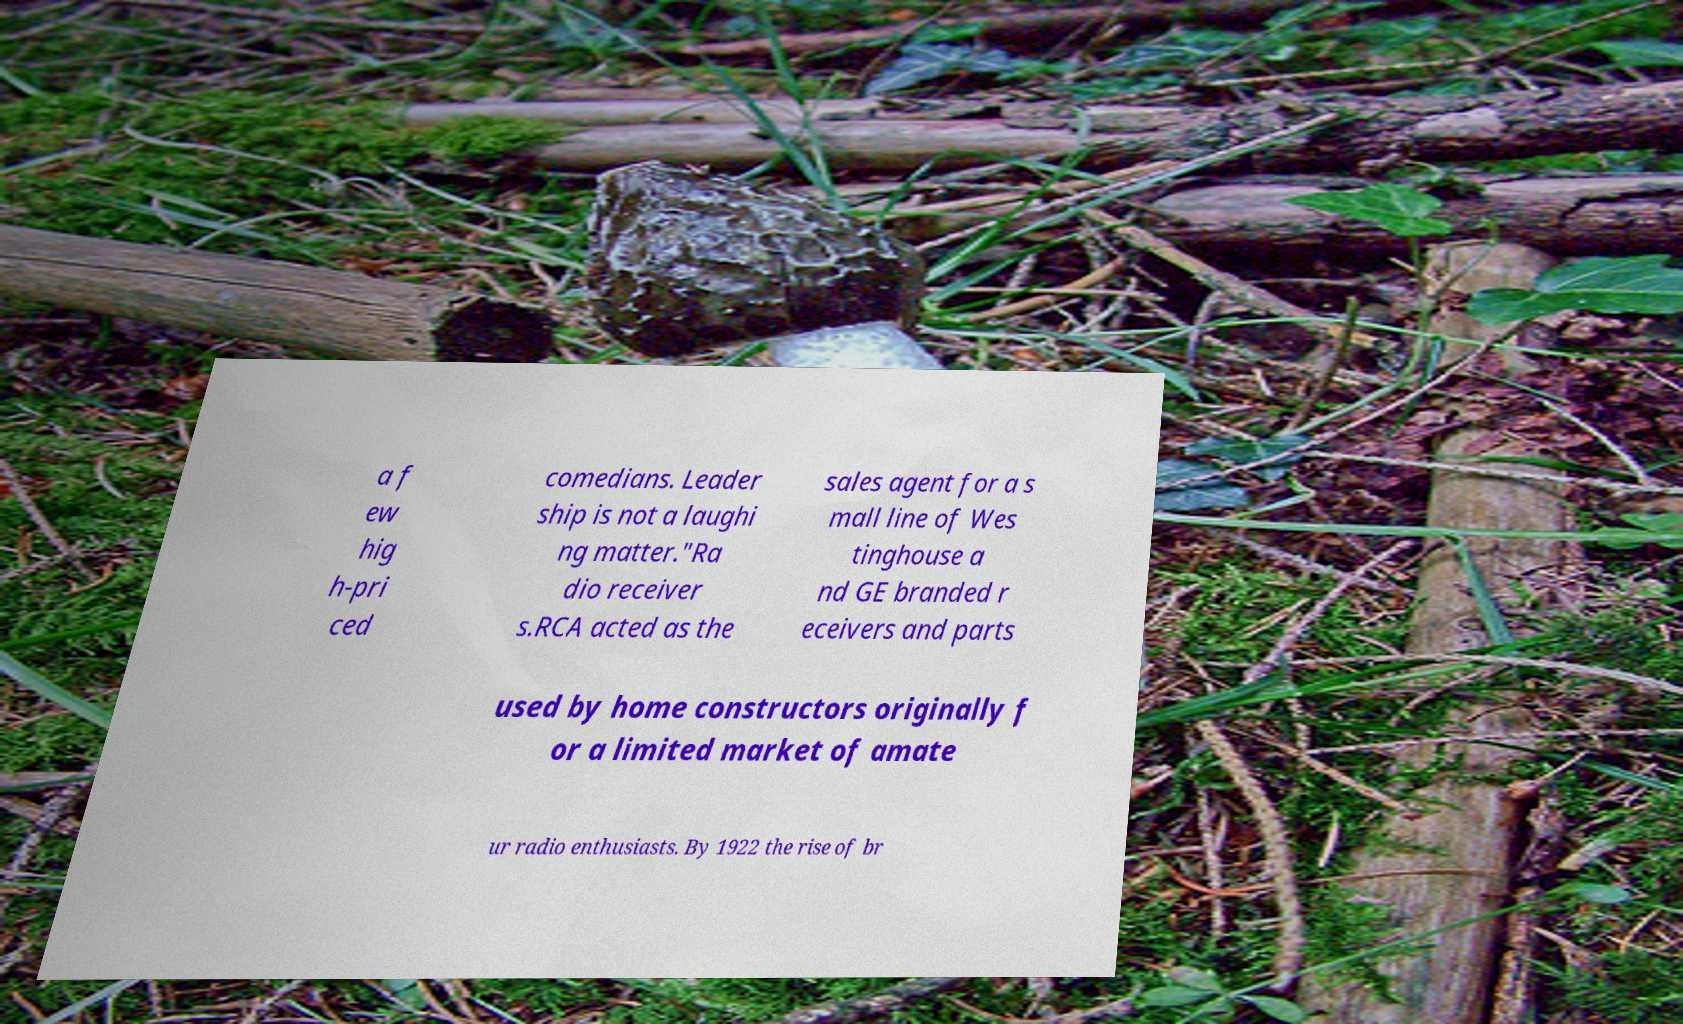What messages or text are displayed in this image? I need them in a readable, typed format. a f ew hig h-pri ced comedians. Leader ship is not a laughi ng matter."Ra dio receiver s.RCA acted as the sales agent for a s mall line of Wes tinghouse a nd GE branded r eceivers and parts used by home constructors originally f or a limited market of amate ur radio enthusiasts. By 1922 the rise of br 